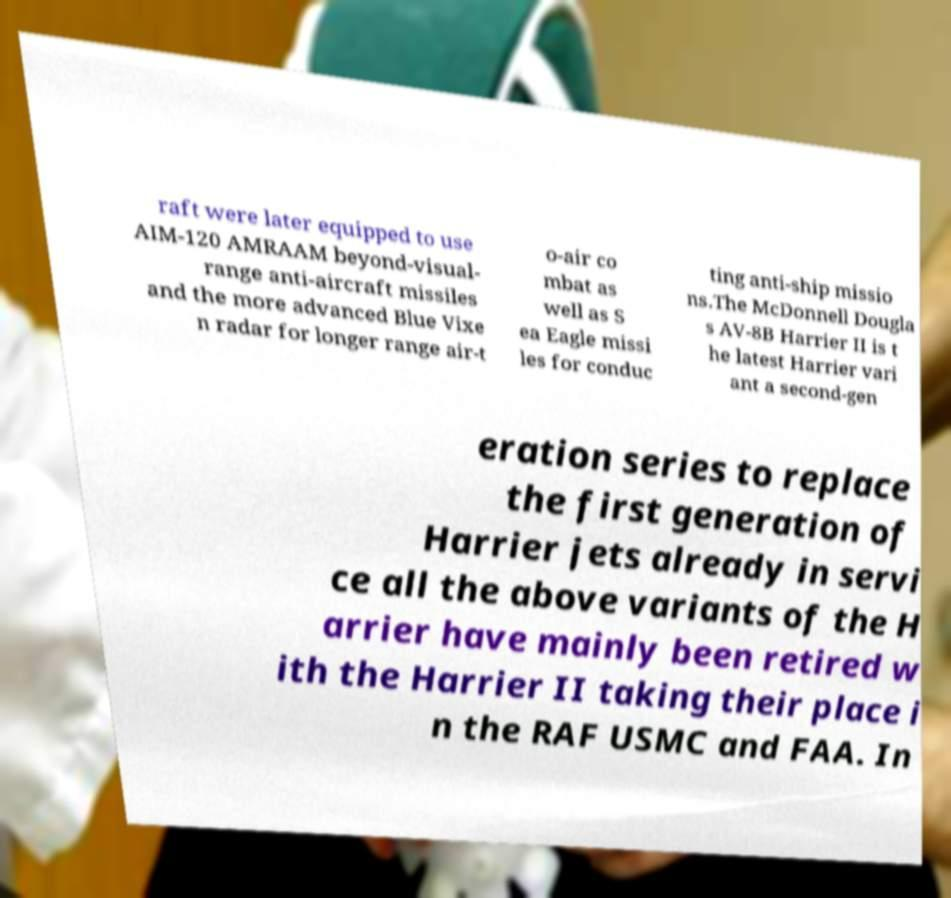Please read and relay the text visible in this image. What does it say? raft were later equipped to use AIM-120 AMRAAM beyond-visual- range anti-aircraft missiles and the more advanced Blue Vixe n radar for longer range air-t o-air co mbat as well as S ea Eagle missi les for conduc ting anti-ship missio ns.The McDonnell Dougla s AV-8B Harrier II is t he latest Harrier vari ant a second-gen eration series to replace the first generation of Harrier jets already in servi ce all the above variants of the H arrier have mainly been retired w ith the Harrier II taking their place i n the RAF USMC and FAA. In 